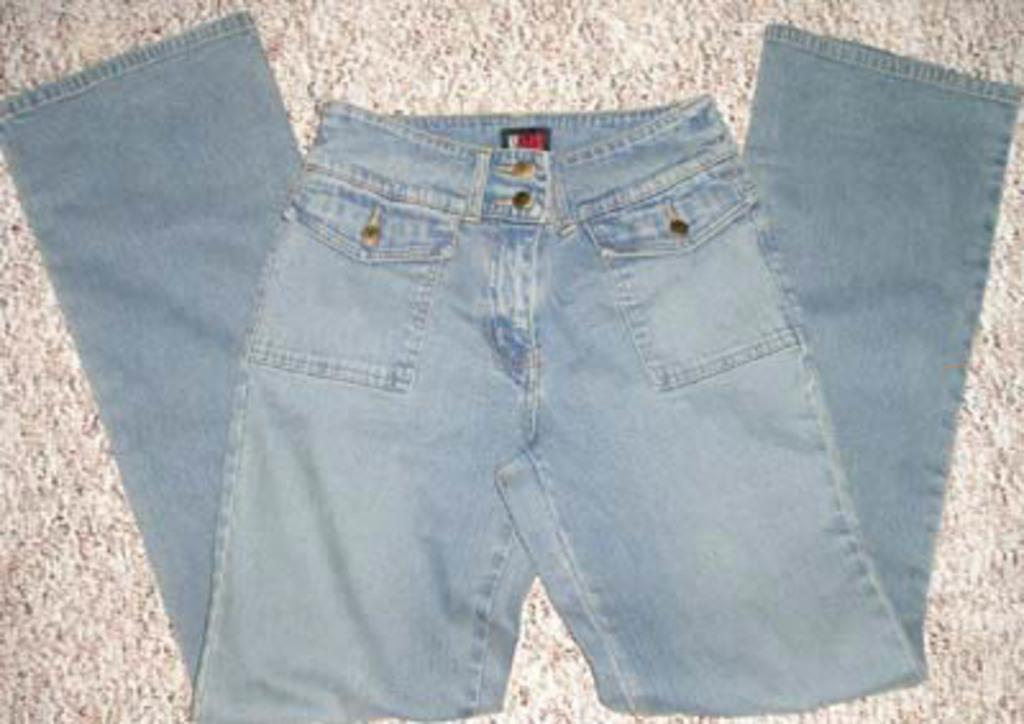What is the main subject of the image? There is a jeans pant in the center of the image. What can be seen in the background of the image? There is a floor visible in the background of the image. How does the jeans pant increase in size in the image? The jeans pant does not increase in size in the image; it remains the same size throughout. 